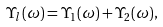<formula> <loc_0><loc_0><loc_500><loc_500>\Upsilon _ { l } ( \omega ) = \Upsilon _ { 1 } ( \omega ) + \Upsilon _ { 2 } ( \omega ) ,</formula> 